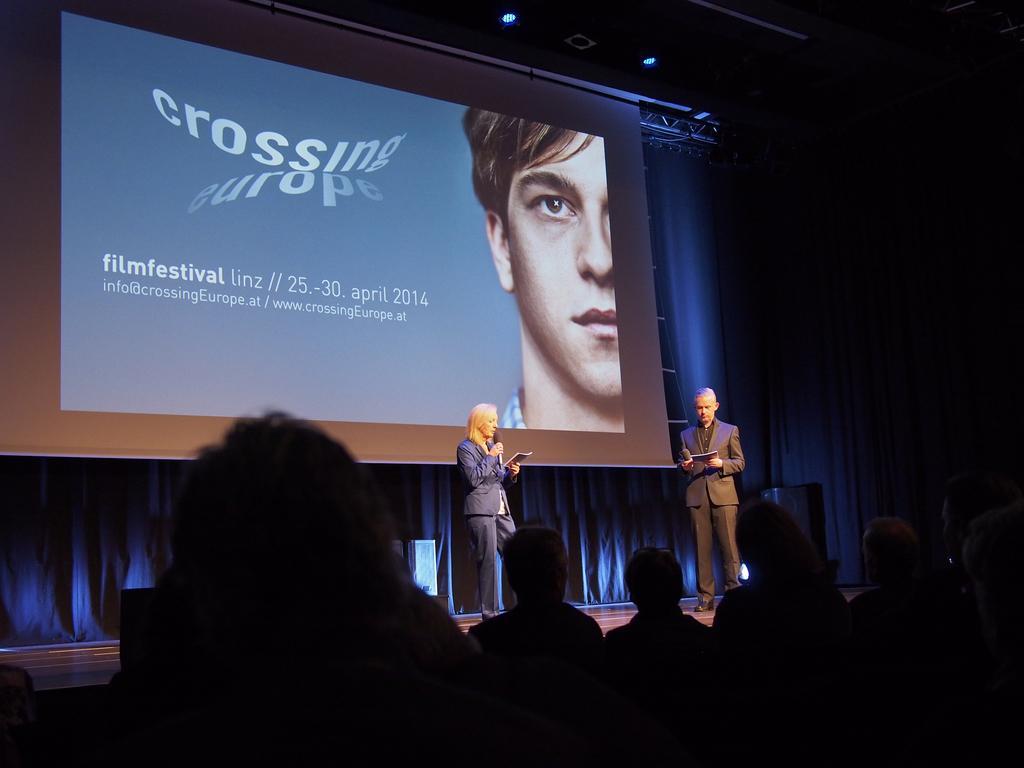Can you describe this image briefly? In this image, I can see two people standing and holding the mikes. This is the screen with the display. I think these are the curtains hanging, which are behind the screen. At the bottom of the image, I can see a group of people. 